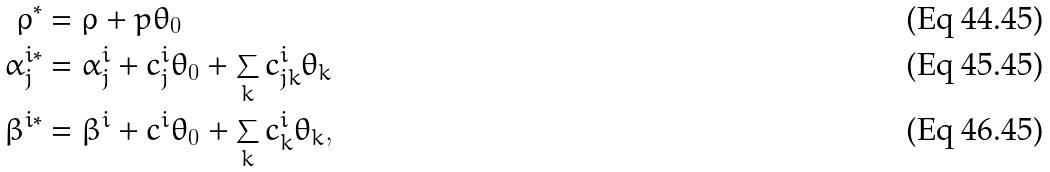Convert formula to latex. <formula><loc_0><loc_0><loc_500><loc_500>\rho ^ { * } & = \rho + p \theta _ { 0 } \\ \alpha ^ { i * } _ { j } & = \alpha ^ { i } _ { j } + c ^ { i } _ { j } \theta _ { 0 } + \sum _ { k } c ^ { i } _ { j k } \theta _ { k } \\ \beta ^ { i * } & = \beta ^ { i } + c ^ { i } \theta _ { 0 } + \sum _ { k } c ^ { i } _ { k } \theta _ { k } ,</formula> 